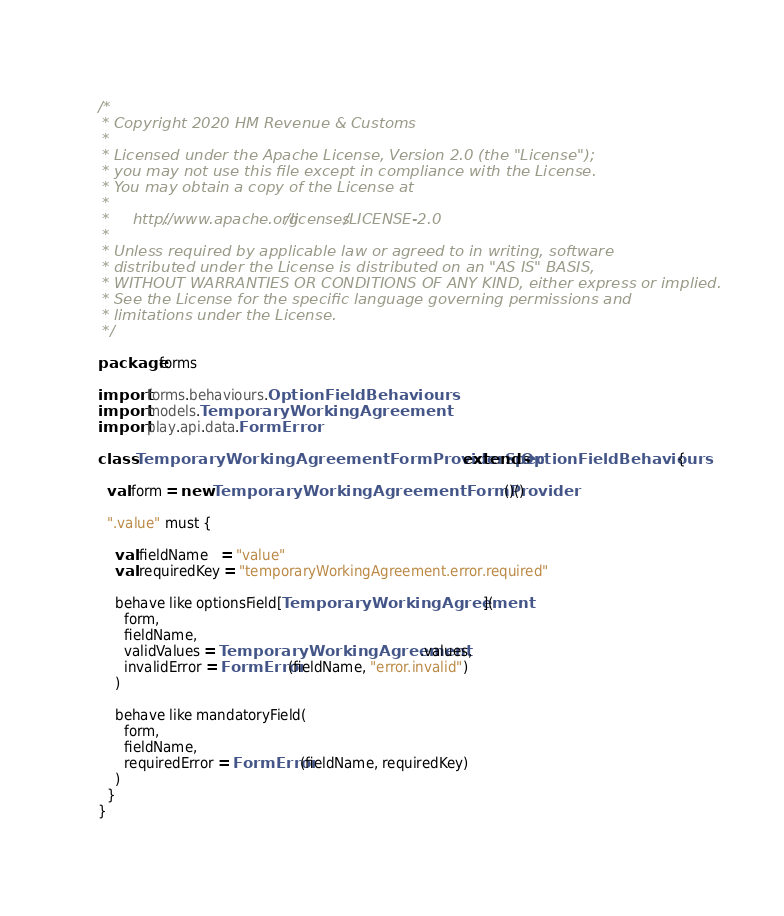<code> <loc_0><loc_0><loc_500><loc_500><_Scala_>/*
 * Copyright 2020 HM Revenue & Customs
 *
 * Licensed under the Apache License, Version 2.0 (the "License");
 * you may not use this file except in compliance with the License.
 * You may obtain a copy of the License at
 *
 *     http://www.apache.org/licenses/LICENSE-2.0
 *
 * Unless required by applicable law or agreed to in writing, software
 * distributed under the License is distributed on an "AS IS" BASIS,
 * WITHOUT WARRANTIES OR CONDITIONS OF ANY KIND, either express or implied.
 * See the License for the specific language governing permissions and
 * limitations under the License.
 */

package forms

import forms.behaviours.OptionFieldBehaviours
import models.TemporaryWorkingAgreement
import play.api.data.FormError

class TemporaryWorkingAgreementFormProviderSpec extends OptionFieldBehaviours {

  val form = new TemporaryWorkingAgreementFormProvider()()

  ".value" must {

    val fieldName   = "value"
    val requiredKey = "temporaryWorkingAgreement.error.required"

    behave like optionsField[TemporaryWorkingAgreement](
      form,
      fieldName,
      validValues = TemporaryWorkingAgreement.values,
      invalidError = FormError(fieldName, "error.invalid")
    )

    behave like mandatoryField(
      form,
      fieldName,
      requiredError = FormError(fieldName, requiredKey)
    )
  }
}
</code> 